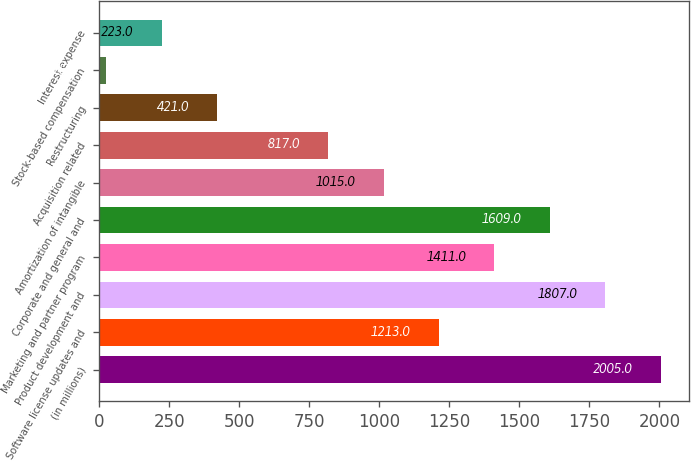Convert chart. <chart><loc_0><loc_0><loc_500><loc_500><bar_chart><fcel>(in millions)<fcel>Software license updates and<fcel>Product development and<fcel>Marketing and partner program<fcel>Corporate and general and<fcel>Amortization of intangible<fcel>Acquisition related<fcel>Restructuring<fcel>Stock-based compensation<fcel>Interest expense<nl><fcel>2005<fcel>1213<fcel>1807<fcel>1411<fcel>1609<fcel>1015<fcel>817<fcel>421<fcel>25<fcel>223<nl></chart> 